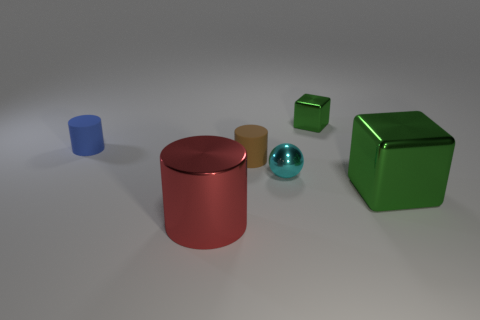Do the cyan ball and the small green cube behind the tiny blue object have the same material?
Your response must be concise. Yes. There is a large thing to the right of the green metal cube to the left of the big green block; what is it made of?
Offer a terse response. Metal. Is the number of large red shiny objects that are in front of the small blue thing greater than the number of large green objects?
Provide a short and direct response. No. Is there a large shiny cube?
Ensure brevity in your answer.  Yes. There is a tiny thing that is behind the small blue cylinder; what color is it?
Provide a succinct answer. Green. There is a cyan object that is the same size as the brown thing; what is it made of?
Offer a terse response. Metal. What number of other things are the same material as the cyan ball?
Give a very brief answer. 3. There is a object that is both to the left of the tiny brown thing and in front of the small brown matte object; what is its color?
Give a very brief answer. Red. What number of objects are either cylinders right of the blue thing or tiny cyan balls?
Offer a very short reply. 3. What number of other objects are there of the same color as the tiny cube?
Keep it short and to the point. 1. 